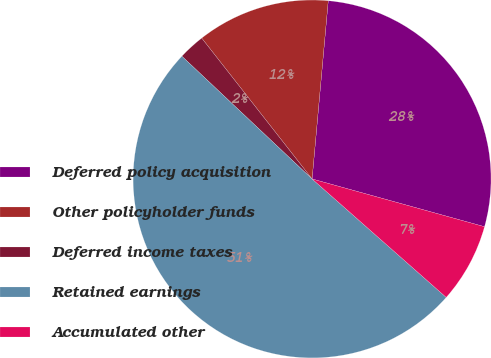Convert chart. <chart><loc_0><loc_0><loc_500><loc_500><pie_chart><fcel>Deferred policy acquisition<fcel>Other policyholder funds<fcel>Deferred income taxes<fcel>Retained earnings<fcel>Accumulated other<nl><fcel>27.86%<fcel>12.02%<fcel>2.39%<fcel>50.52%<fcel>7.21%<nl></chart> 